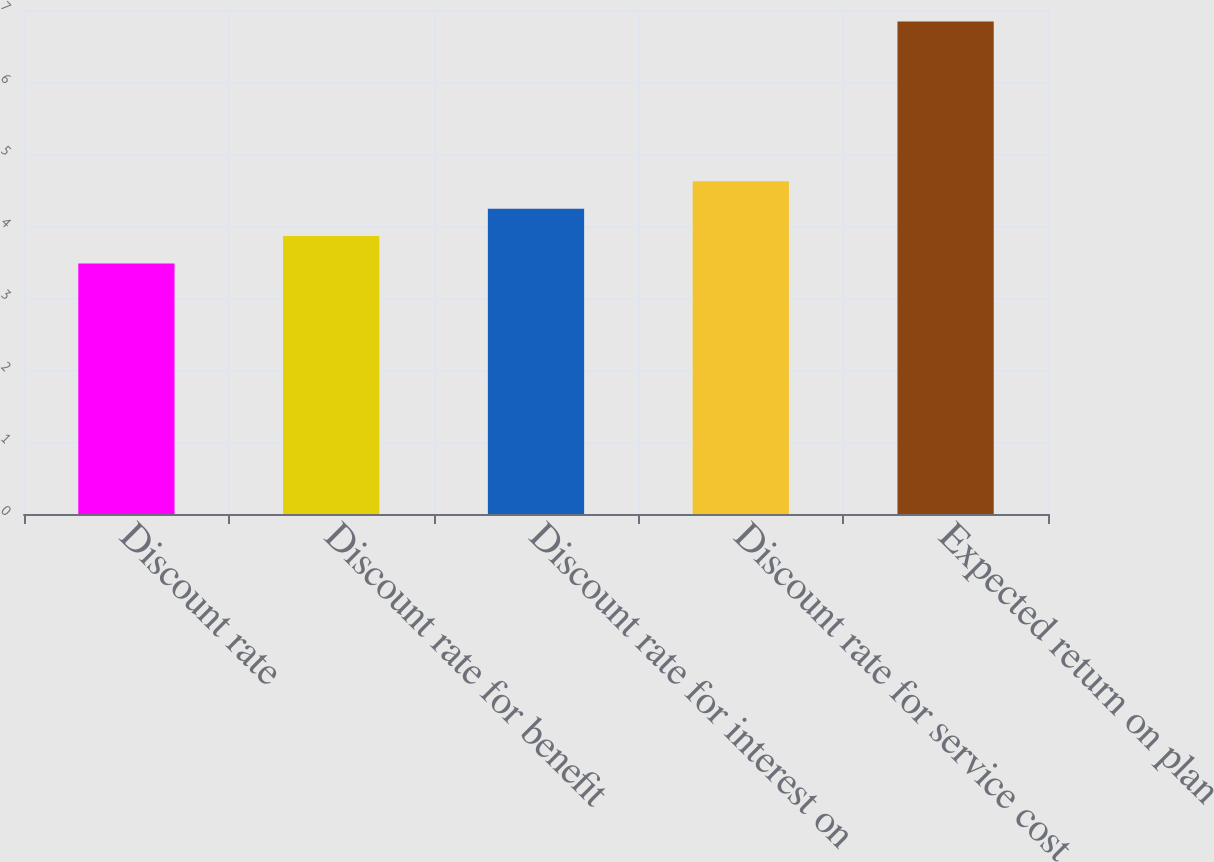<chart> <loc_0><loc_0><loc_500><loc_500><bar_chart><fcel>Discount rate<fcel>Discount rate for benefit<fcel>Discount rate for interest on<fcel>Discount rate for service cost<fcel>Expected return on plan<nl><fcel>3.48<fcel>3.86<fcel>4.24<fcel>4.62<fcel>6.84<nl></chart> 